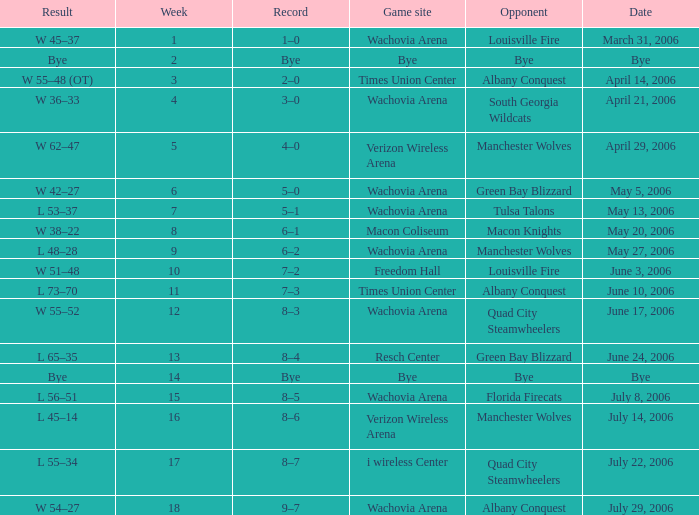What is the Game site week 1? Wachovia Arena. 